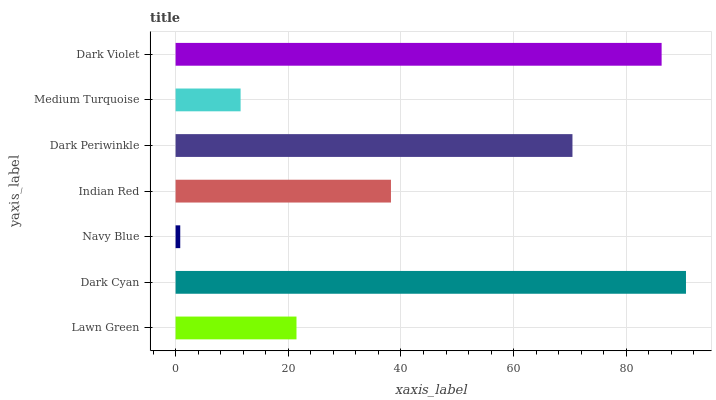Is Navy Blue the minimum?
Answer yes or no. Yes. Is Dark Cyan the maximum?
Answer yes or no. Yes. Is Dark Cyan the minimum?
Answer yes or no. No. Is Navy Blue the maximum?
Answer yes or no. No. Is Dark Cyan greater than Navy Blue?
Answer yes or no. Yes. Is Navy Blue less than Dark Cyan?
Answer yes or no. Yes. Is Navy Blue greater than Dark Cyan?
Answer yes or no. No. Is Dark Cyan less than Navy Blue?
Answer yes or no. No. Is Indian Red the high median?
Answer yes or no. Yes. Is Indian Red the low median?
Answer yes or no. Yes. Is Navy Blue the high median?
Answer yes or no. No. Is Navy Blue the low median?
Answer yes or no. No. 